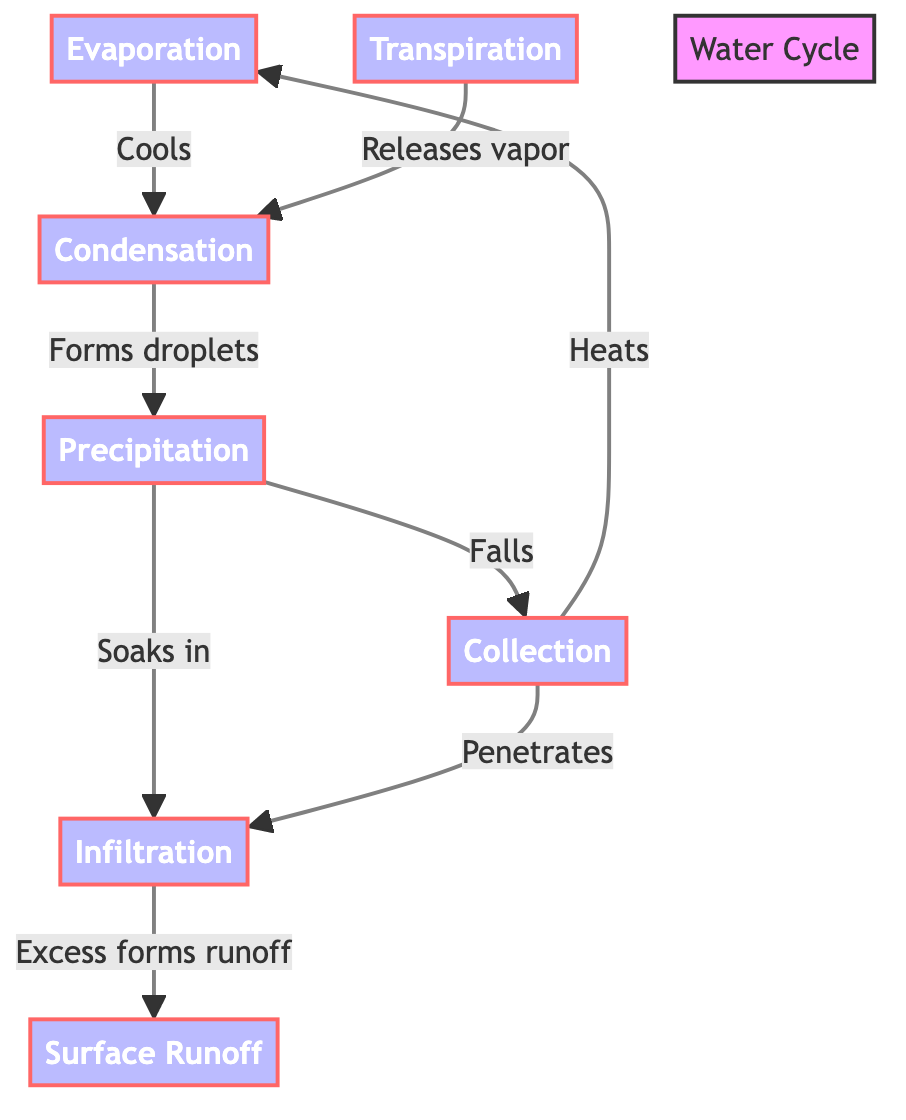What is the first process in the water cycle? The diagram shows that the first process is Evaporation, which is positioned at the start of the flowchart as node A. It represents the initial stage of the water cycle.
Answer: Evaporation How many major processes are identified in the diagram? By counting the nodes in the flowchart, we see there are six identifiable major processes: Evaporation, Condensation, Precipitation, Collection, Infiltration, and Surface Runoff.
Answer: Six What relationship exists between Collection and Evaporation? The diagram indicates that Collection leads to Evaporation through a heating process mentioned in the connection labeled "Heats." This shows the cyclical nature of these processes.
Answer: Heats What process follows Condensation in the diagram? Following the flow from the diagram, Condensation is connected to Precipitation, indicating that condensation leads to the formation of precipitation next.
Answer: Precipitation What role does Transpiration play in the diagram? The diagram shows that Transpiration releases vapor into the process of Condensation, indicating it plays a part in contributing to the formation of clouds and precipitation.
Answer: Releases vapor What happens to the water after it is absorbed during Infiltration? The diagram shows that after Infiltration, excess water forms Surface Runoff, indicating that not all water is absorbed into the ground, some will flow over the surface.
Answer: Forms runoff Which process is involved in both Collection and Infiltration? Looking at the diagram, both Collection and Infiltration connect to the process of Surface Runoff, demonstrating that Surface Runoff is a result of both processes influencing water movement.
Answer: Surface Runoff How does Precipitation interact with Collection? The diagram illustrates that Precipitation falls into Collection, indicating that precipitation directly contributes to the accumulation of water in collection areas like rivers or lakes.
Answer: Falls 